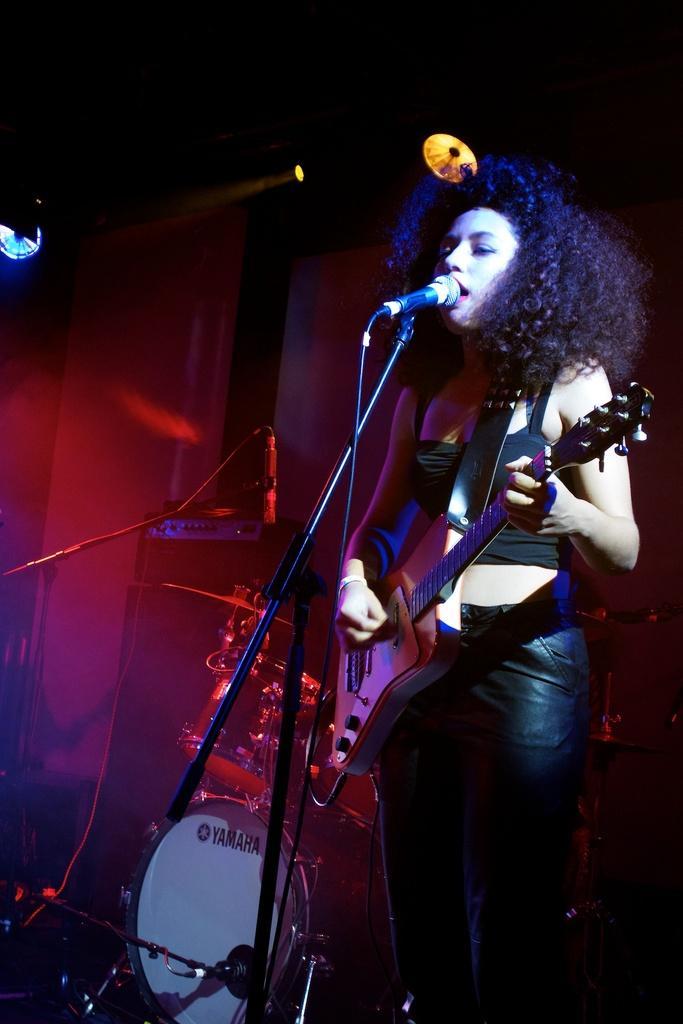Can you describe this image briefly? In this picture there is a person standing and holding guitar. There is microphone with stand. There is a drum. In this background we can see lights. 